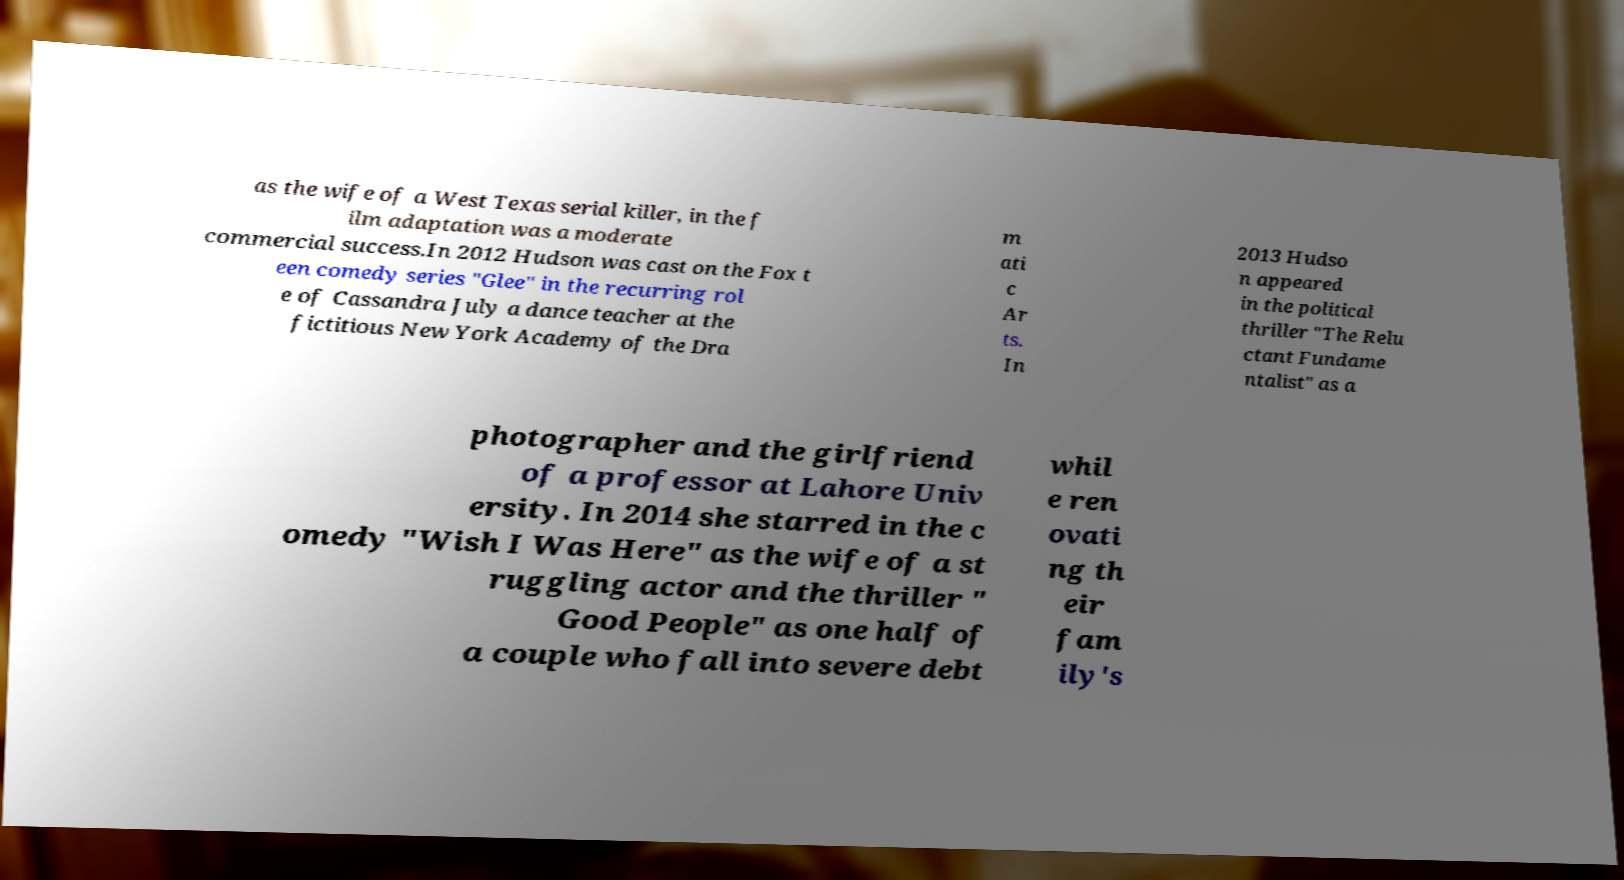I need the written content from this picture converted into text. Can you do that? as the wife of a West Texas serial killer, in the f ilm adaptation was a moderate commercial success.In 2012 Hudson was cast on the Fox t een comedy series "Glee" in the recurring rol e of Cassandra July a dance teacher at the fictitious New York Academy of the Dra m ati c Ar ts. In 2013 Hudso n appeared in the political thriller "The Relu ctant Fundame ntalist" as a photographer and the girlfriend of a professor at Lahore Univ ersity. In 2014 she starred in the c omedy "Wish I Was Here" as the wife of a st ruggling actor and the thriller " Good People" as one half of a couple who fall into severe debt whil e ren ovati ng th eir fam ily's 